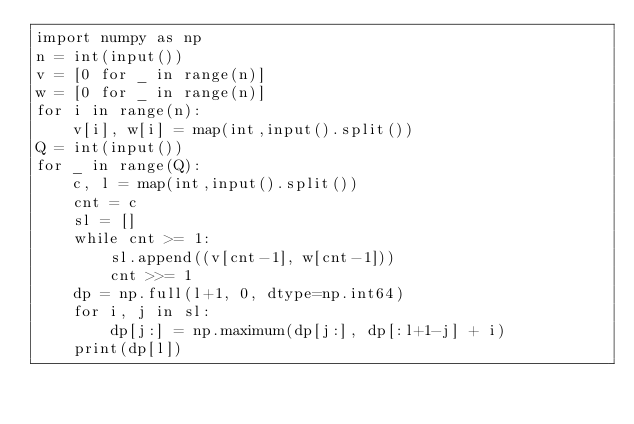Convert code to text. <code><loc_0><loc_0><loc_500><loc_500><_Python_>import numpy as np
n = int(input())
v = [0 for _ in range(n)]
w = [0 for _ in range(n)]
for i in range(n):
	v[i], w[i] = map(int,input().split())
Q = int(input())
for _ in range(Q):
	c, l = map(int,input().split())
	cnt = c
	sl = []
	while cnt >= 1:
		sl.append((v[cnt-1], w[cnt-1]))
		cnt >>= 1
	dp = np.full(l+1, 0, dtype=np.int64)
	for i, j in sl:
		dp[j:] = np.maximum(dp[j:], dp[:l+1-j] + i)
	print(dp[l])</code> 